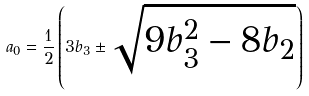Convert formula to latex. <formula><loc_0><loc_0><loc_500><loc_500>a _ { 0 } = \frac { 1 } { 2 } \left ( 3 b _ { 3 } \pm \sqrt { 9 b _ { 3 } ^ { 2 } - 8 b _ { 2 } } \right )</formula> 